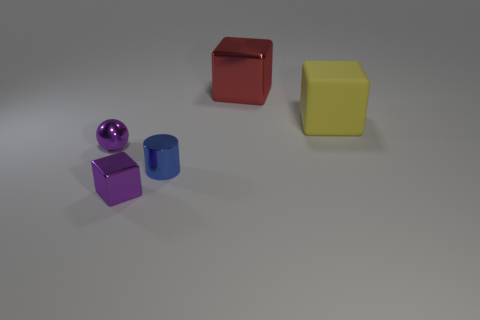Is there a purple block that has the same size as the matte thing?
Offer a terse response. No. There is a purple metal object that is behind the purple object right of the small purple ball; are there any tiny metal things that are in front of it?
Offer a terse response. Yes. Does the shiny ball have the same color as the cube that is to the left of the big red thing?
Give a very brief answer. Yes. There is a large yellow block to the right of the small purple metal thing left of the metallic cube in front of the metal sphere; what is it made of?
Keep it short and to the point. Rubber. There is a purple thing in front of the purple ball; what shape is it?
Your answer should be compact. Cube. The red thing that is the same material as the tiny purple cube is what size?
Give a very brief answer. Large. What number of yellow things have the same shape as the red metallic object?
Offer a terse response. 1. Do the block on the left side of the large red object and the shiny sphere have the same color?
Provide a succinct answer. Yes. What number of tiny blue metallic things are to the left of the shiny block that is on the left side of the object behind the large yellow object?
Make the answer very short. 0. What number of cubes are both on the right side of the large red thing and in front of the blue shiny object?
Offer a very short reply. 0. 